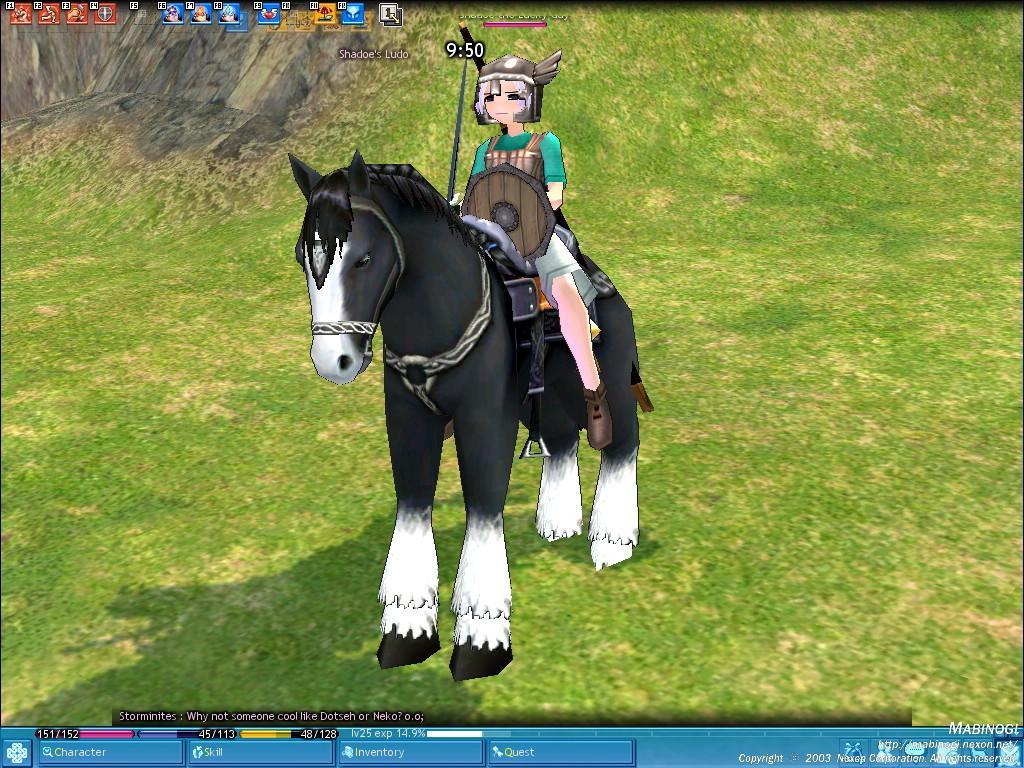Please provide a concise description of this image. This is an animated web page. In the center of the image we can see a person is riding a horse. In the background of the image we can see the grass, rock, logos and text. 